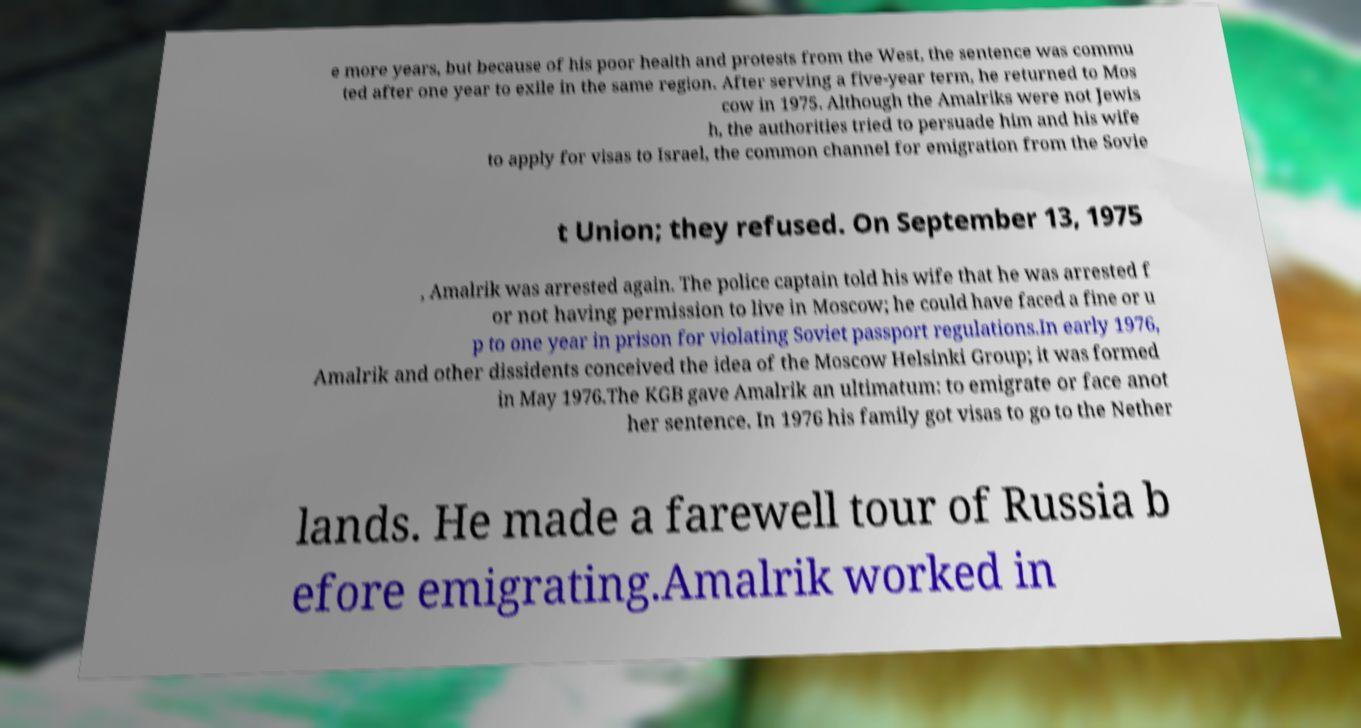What messages or text are displayed in this image? I need them in a readable, typed format. e more years, but because of his poor health and protests from the West, the sentence was commu ted after one year to exile in the same region. After serving a five-year term, he returned to Mos cow in 1975. Although the Amalriks were not Jewis h, the authorities tried to persuade him and his wife to apply for visas to Israel, the common channel for emigration from the Sovie t Union; they refused. On September 13, 1975 , Amalrik was arrested again. The police captain told his wife that he was arrested f or not having permission to live in Moscow; he could have faced a fine or u p to one year in prison for violating Soviet passport regulations.In early 1976, Amalrik and other dissidents conceived the idea of the Moscow Helsinki Group; it was formed in May 1976.The KGB gave Amalrik an ultimatum: to emigrate or face anot her sentence. In 1976 his family got visas to go to the Nether lands. He made a farewell tour of Russia b efore emigrating.Amalrik worked in 